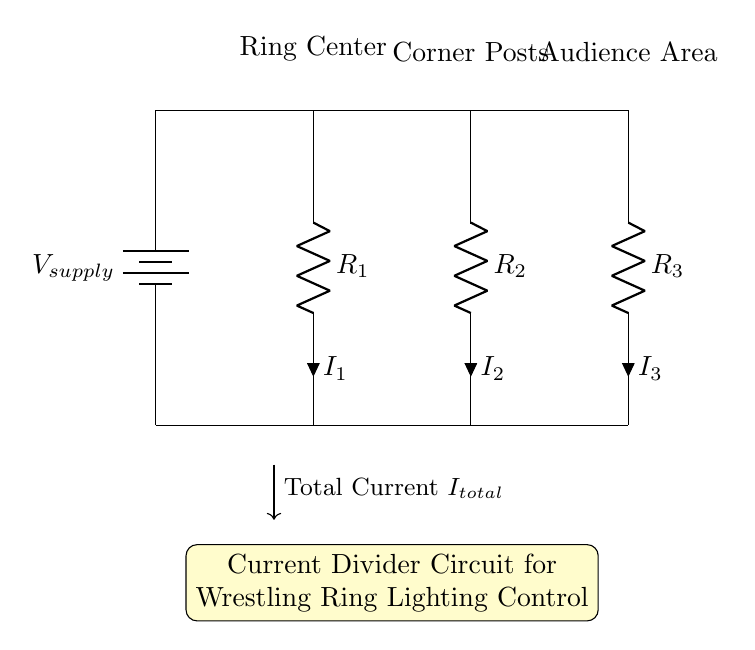What is the total current represented in the circuit? The total current is indicated by the label 'I_total' pointing down from the battery source, representing the current flowing through the overall circuit.
Answer: I_total What are the resistance values of the components in the circuit? The circuit diagram labels three resistors as R1, R2, and R3, but does not provide specific numerical values, so they are referred to generically.
Answer: R1, R2, R3 Where is the supply voltage connected in the circuit? The supply voltage is connected to the circuit at the top, with the positive terminal of the battery at the point marked 'V_supply' on the left side, from where the current flows downward into the circuit.
Answer: Left side What happens to the current as it flows through the resistors in this circuit? The current divides among the resistors R1, R2, and R3 according to their resistance values; lower resistance draws more current, while higher resistance draws less, following the principles of the current divider rule.
Answer: Divides If R2 is halved, what happens to the current through R2? Halving R2 would increase the current through it because the total current would split according to the new resistance ratio defined by the current divider rule; more current goes through the lower resistance.
Answer: Increases What type of circuit is shown in this diagram? This is a current divider circuit, specifically designed to control the distribution of current across multiple parallel resistive loads, suitable for applications like lighting control.
Answer: Current divider circuit 